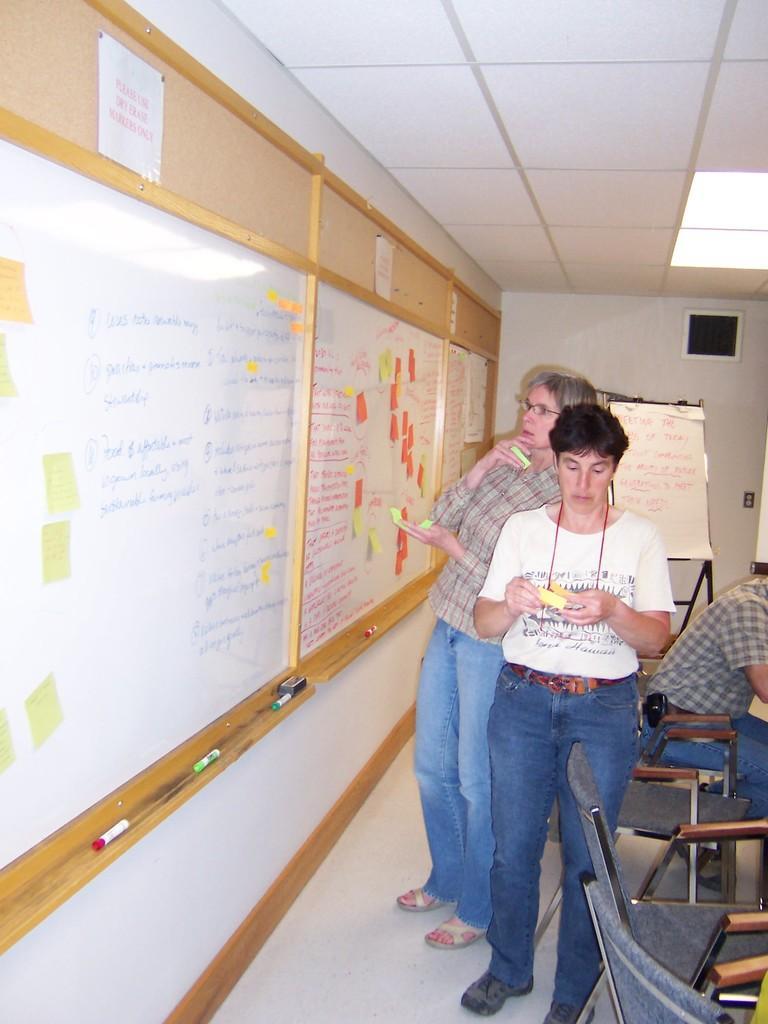Describe this image in one or two sentences. In this picture we can see three persons where one person is sitting on chair and other two are standing looking at board and in background we can see notice, wall, light. 